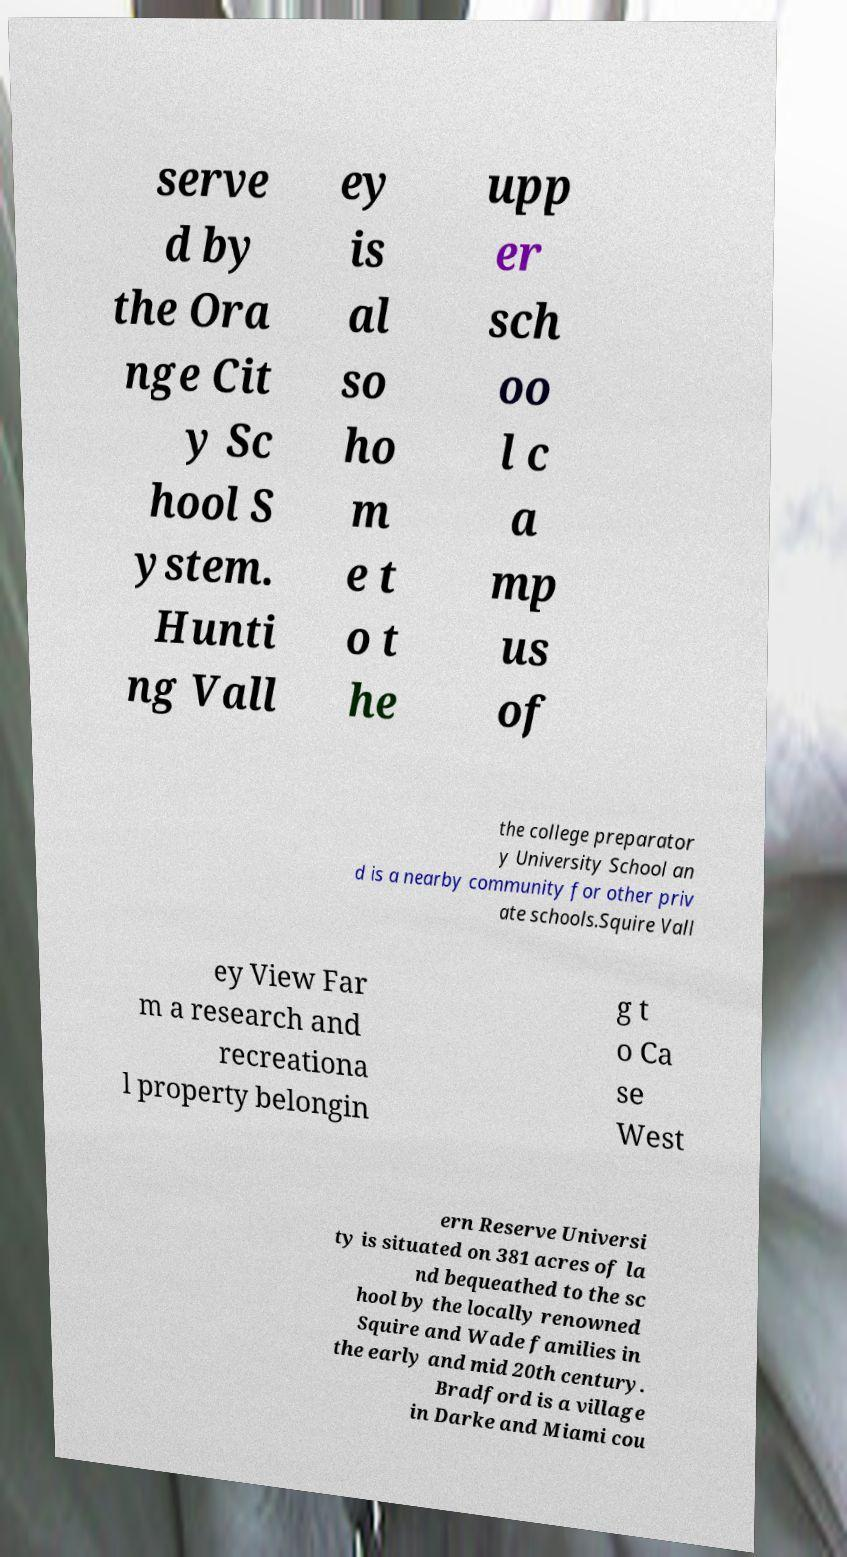For documentation purposes, I need the text within this image transcribed. Could you provide that? serve d by the Ora nge Cit y Sc hool S ystem. Hunti ng Vall ey is al so ho m e t o t he upp er sch oo l c a mp us of the college preparator y University School an d is a nearby community for other priv ate schools.Squire Vall ey View Far m a research and recreationa l property belongin g t o Ca se West ern Reserve Universi ty is situated on 381 acres of la nd bequeathed to the sc hool by the locally renowned Squire and Wade families in the early and mid 20th century. Bradford is a village in Darke and Miami cou 